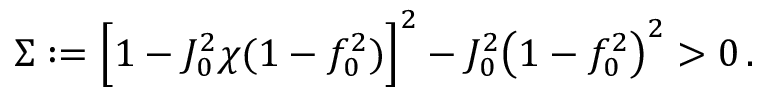Convert formula to latex. <formula><loc_0><loc_0><loc_500><loc_500>\Sigma \colon = \left [ 1 - J _ { 0 } ^ { 2 } \chi ( 1 - f _ { 0 } ^ { 2 } ) \right ] ^ { 2 } - J _ { 0 } ^ { 2 } \left ( 1 - f _ { 0 } ^ { 2 } \right ) ^ { 2 } > 0 \, .</formula> 